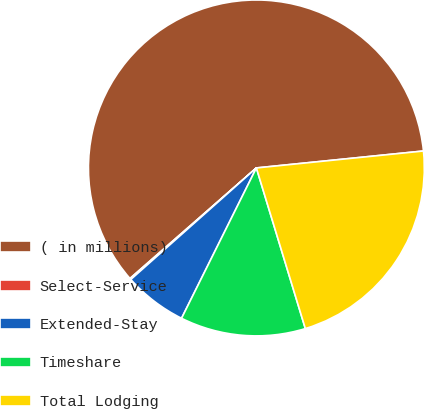Convert chart to OTSL. <chart><loc_0><loc_0><loc_500><loc_500><pie_chart><fcel>( in millions)<fcel>Select-Service<fcel>Extended-Stay<fcel>Timeshare<fcel>Total Lodging<nl><fcel>59.83%<fcel>0.12%<fcel>6.09%<fcel>12.06%<fcel>21.9%<nl></chart> 